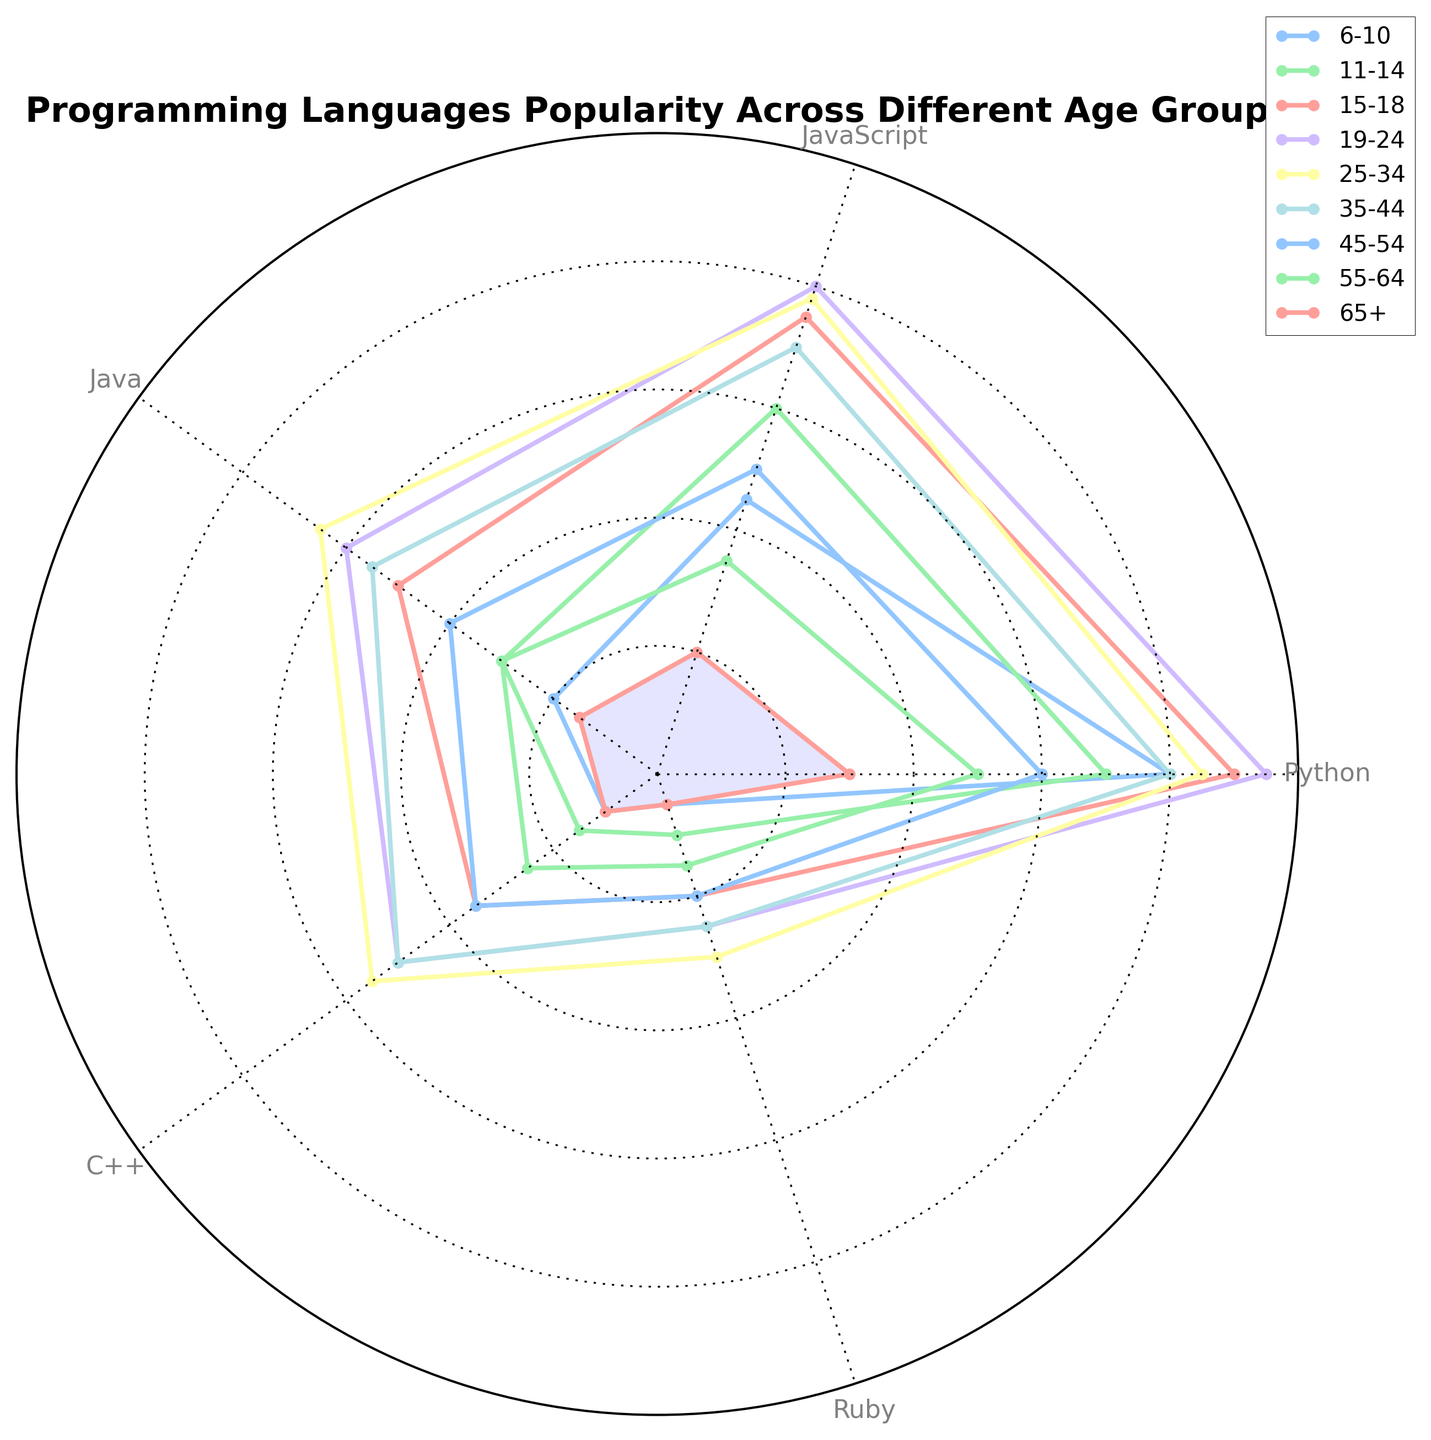What age group has the highest popularity for Python? By looking at the data points for Python on the radar chart, we can see which age group has the largest value. The value is highest at the 19-24 age group.
Answer: 19-24 Which programming language is the least popular among the 6-10 age group? By looking at the data points in the chart for the 6-10 age group, we can see which language has the smallest value. The least popular programming language for this age group is Ruby.
Answer: Ruby Which two age groups have the closest popularity levels for JavaScript? Comparing the values of JavaScript across different age groups, we find that the 25-34 age group (78) and 15-18 age group (75) have the closest values.
Answer: 25-34 and 15-18 What is the difference in popularity of C++ between the 19-24 and 25-34 age groups? The value for C++ in the 19-24 age group is 50, and in the 25-34 age group is 55. Subtracting these values, 55 - 50 = 5.
Answer: 5 Which age group has the lowest combined popularity score for Java and Ruby? Adding the popularity scores for Java and Ruby across all age groups, the values are: 
6-10: 20+5=25 
11-14: 30+10=40 
15-18: 50+20=70 
19-24: 60+25=85 
25-34: 65+30=95 
35-44: 55+25=80 
45-54: 40+20=60 
55-64: 30+15=45 
65+: 15+5=20 
The lowest combined score is for the 65+ age group with 20.
Answer: 65+ For the age group 15-18, which language has a higher popularity: Java or C++? By looking at the radar chart, we compare the values of Java and C++ for the 15-18 age group. Java is 50, and C++ is 35. Thus, Java has a higher popularity.
Answer: Java How does the popularity of Python change from the 55-64 age group to the 19-24 age group? By looking at the data, the popularity of Python for the 55-64 age group is 50, and for the 19-24 age group, it is 95. There is an increase of 95 - 50 = 45.
Answer: It increases by 45 What are the average popularity scores of Ruby across all age groups? Summing the popularity scores for Ruby across all age groups, we find: 5 + 10 + 20 + 25 + 30 + 25 + 20 + 15 + 5 = 155. Dividing by the number of age groups (9), 155 / 9 = 17.22 (approximately).
Answer: 17.22 Which programming language shows the most consistent popularity across different age groups? By looking at the radar chart, we can see which language has lines that are closest together in value across different age groups. Python shows a high level of consistency.
Answer: Python In the age group 45-54, how many languages have popularity scores that are above 30? By looking at the values for the 45-54 age group on the radar chart, we see that Python (60), JavaScript (50), Java (40), and C++ (35) are all above 30. Thus, there are four languages above 30.
Answer: 4 